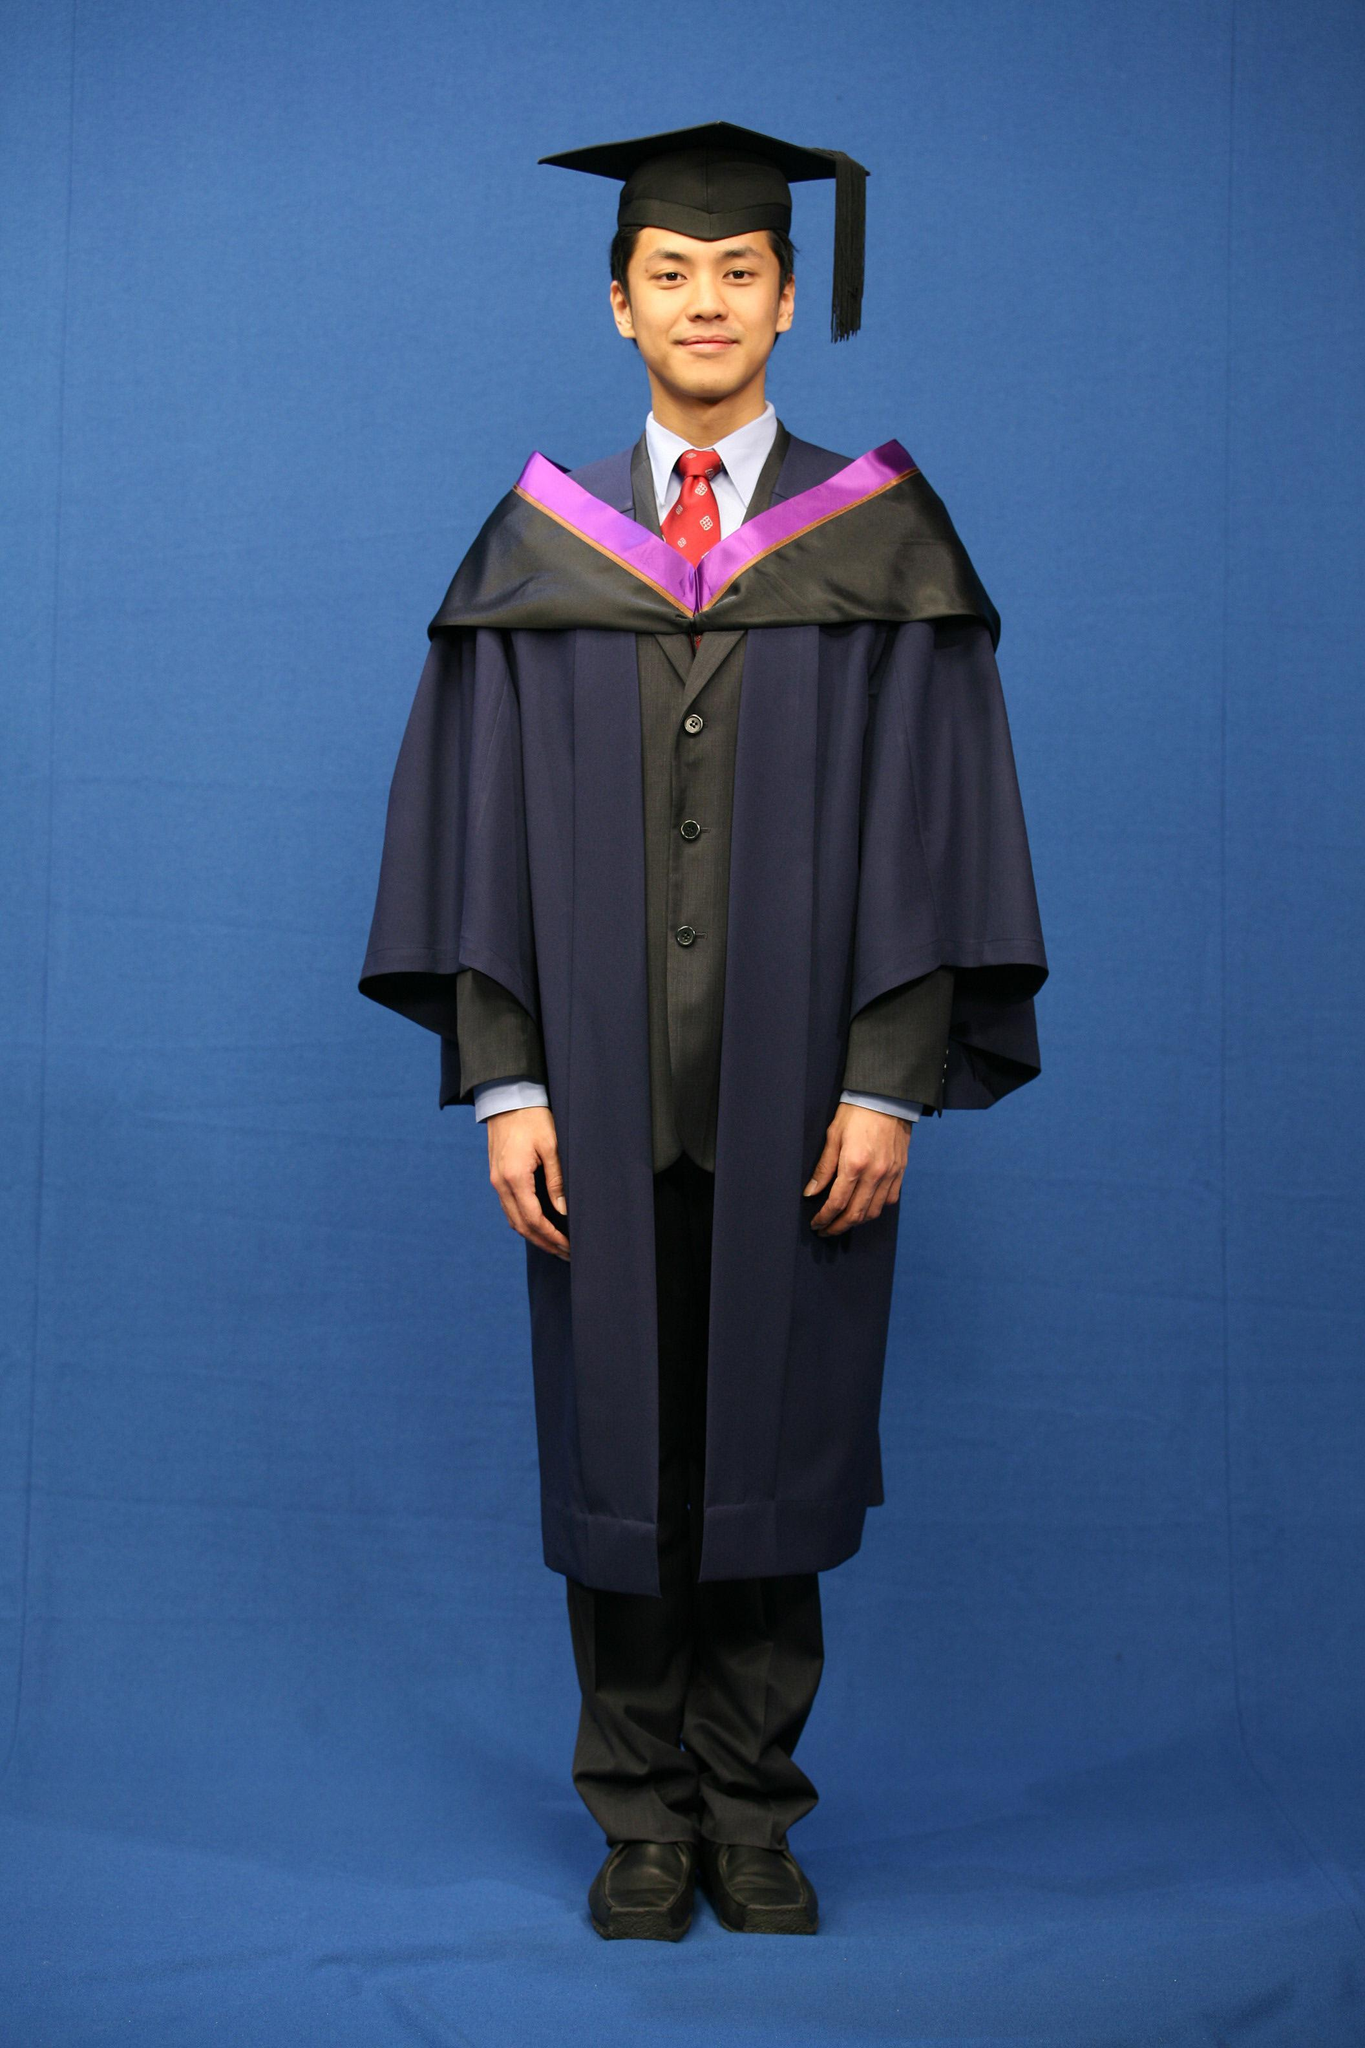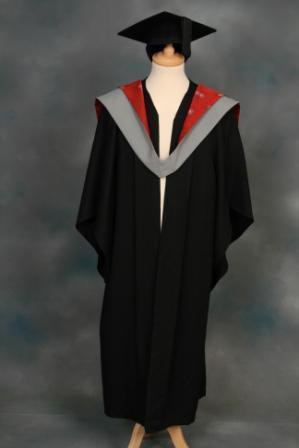The first image is the image on the left, the second image is the image on the right. Analyze the images presented: Is the assertion "The left image shows exactly one male in graduation garb." valid? Answer yes or no. Yes. The first image is the image on the left, the second image is the image on the right. Given the left and right images, does the statement "One image contains at least one living young male model." hold true? Answer yes or no. Yes. 